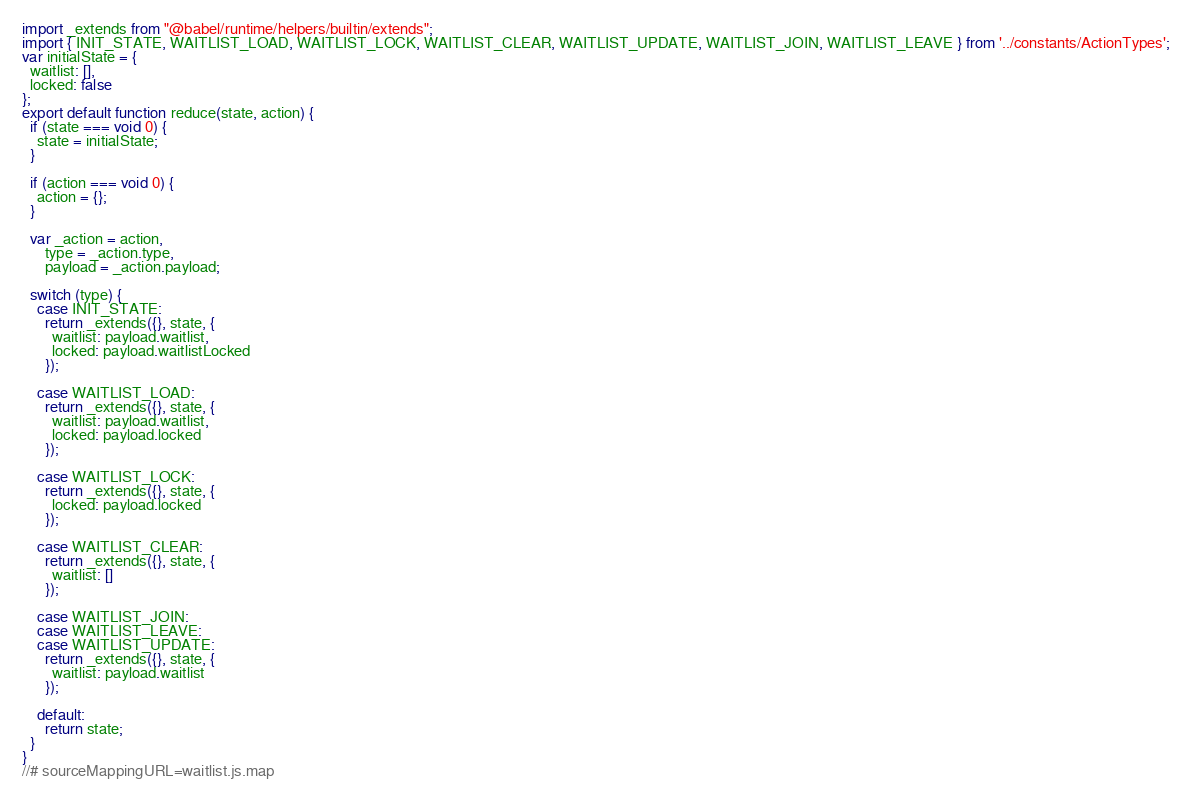<code> <loc_0><loc_0><loc_500><loc_500><_JavaScript_>import _extends from "@babel/runtime/helpers/builtin/extends";
import { INIT_STATE, WAITLIST_LOAD, WAITLIST_LOCK, WAITLIST_CLEAR, WAITLIST_UPDATE, WAITLIST_JOIN, WAITLIST_LEAVE } from '../constants/ActionTypes';
var initialState = {
  waitlist: [],
  locked: false
};
export default function reduce(state, action) {
  if (state === void 0) {
    state = initialState;
  }

  if (action === void 0) {
    action = {};
  }

  var _action = action,
      type = _action.type,
      payload = _action.payload;

  switch (type) {
    case INIT_STATE:
      return _extends({}, state, {
        waitlist: payload.waitlist,
        locked: payload.waitlistLocked
      });

    case WAITLIST_LOAD:
      return _extends({}, state, {
        waitlist: payload.waitlist,
        locked: payload.locked
      });

    case WAITLIST_LOCK:
      return _extends({}, state, {
        locked: payload.locked
      });

    case WAITLIST_CLEAR:
      return _extends({}, state, {
        waitlist: []
      });

    case WAITLIST_JOIN:
    case WAITLIST_LEAVE:
    case WAITLIST_UPDATE:
      return _extends({}, state, {
        waitlist: payload.waitlist
      });

    default:
      return state;
  }
}
//# sourceMappingURL=waitlist.js.map
</code> 